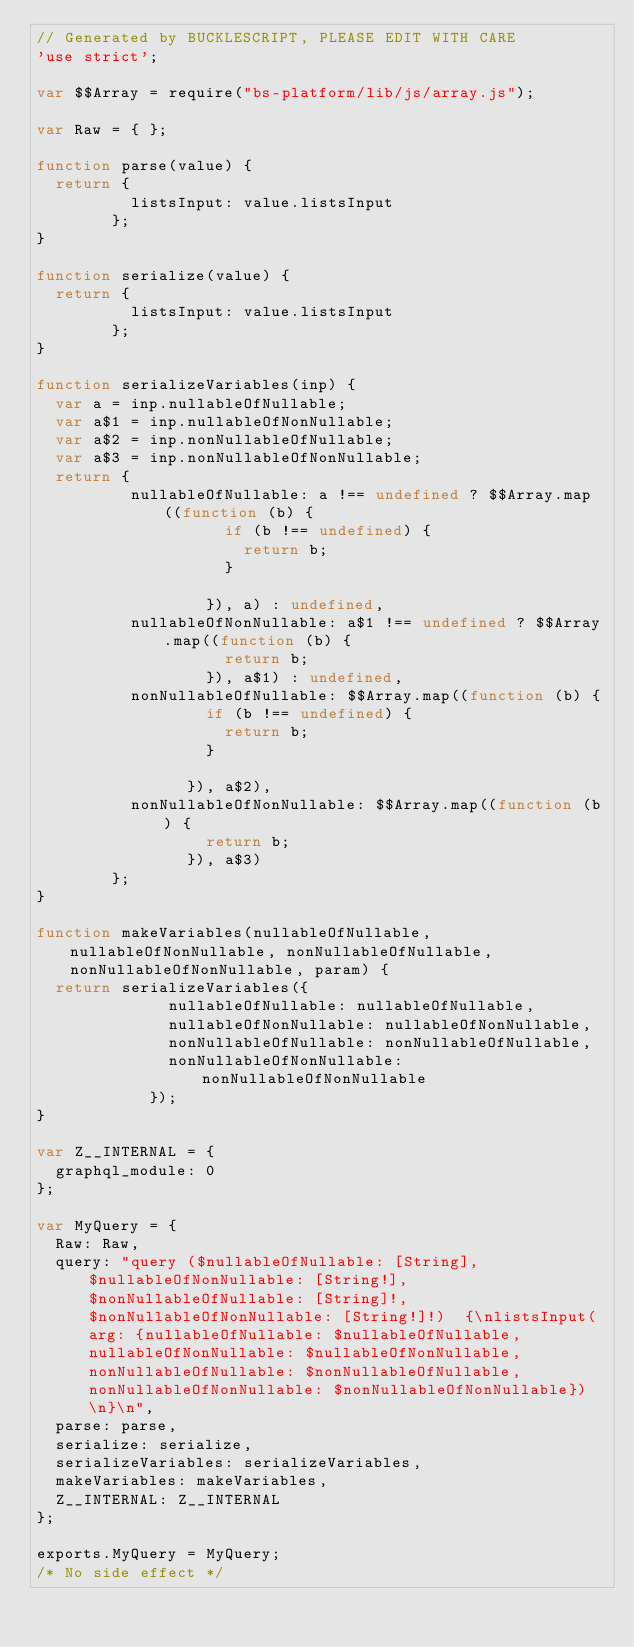Convert code to text. <code><loc_0><loc_0><loc_500><loc_500><_JavaScript_>// Generated by BUCKLESCRIPT, PLEASE EDIT WITH CARE
'use strict';

var $$Array = require("bs-platform/lib/js/array.js");

var Raw = { };

function parse(value) {
  return {
          listsInput: value.listsInput
        };
}

function serialize(value) {
  return {
          listsInput: value.listsInput
        };
}

function serializeVariables(inp) {
  var a = inp.nullableOfNullable;
  var a$1 = inp.nullableOfNonNullable;
  var a$2 = inp.nonNullableOfNullable;
  var a$3 = inp.nonNullableOfNonNullable;
  return {
          nullableOfNullable: a !== undefined ? $$Array.map((function (b) {
                    if (b !== undefined) {
                      return b;
                    }
                    
                  }), a) : undefined,
          nullableOfNonNullable: a$1 !== undefined ? $$Array.map((function (b) {
                    return b;
                  }), a$1) : undefined,
          nonNullableOfNullable: $$Array.map((function (b) {
                  if (b !== undefined) {
                    return b;
                  }
                  
                }), a$2),
          nonNullableOfNonNullable: $$Array.map((function (b) {
                  return b;
                }), a$3)
        };
}

function makeVariables(nullableOfNullable, nullableOfNonNullable, nonNullableOfNullable, nonNullableOfNonNullable, param) {
  return serializeVariables({
              nullableOfNullable: nullableOfNullable,
              nullableOfNonNullable: nullableOfNonNullable,
              nonNullableOfNullable: nonNullableOfNullable,
              nonNullableOfNonNullable: nonNullableOfNonNullable
            });
}

var Z__INTERNAL = {
  graphql_module: 0
};

var MyQuery = {
  Raw: Raw,
  query: "query ($nullableOfNullable: [String], $nullableOfNonNullable: [String!], $nonNullableOfNullable: [String]!, $nonNullableOfNonNullable: [String!]!)  {\nlistsInput(arg: {nullableOfNullable: $nullableOfNullable, nullableOfNonNullable: $nullableOfNonNullable, nonNullableOfNullable: $nonNullableOfNullable, nonNullableOfNonNullable: $nonNullableOfNonNullable})  \n}\n",
  parse: parse,
  serialize: serialize,
  serializeVariables: serializeVariables,
  makeVariables: makeVariables,
  Z__INTERNAL: Z__INTERNAL
};

exports.MyQuery = MyQuery;
/* No side effect */
</code> 